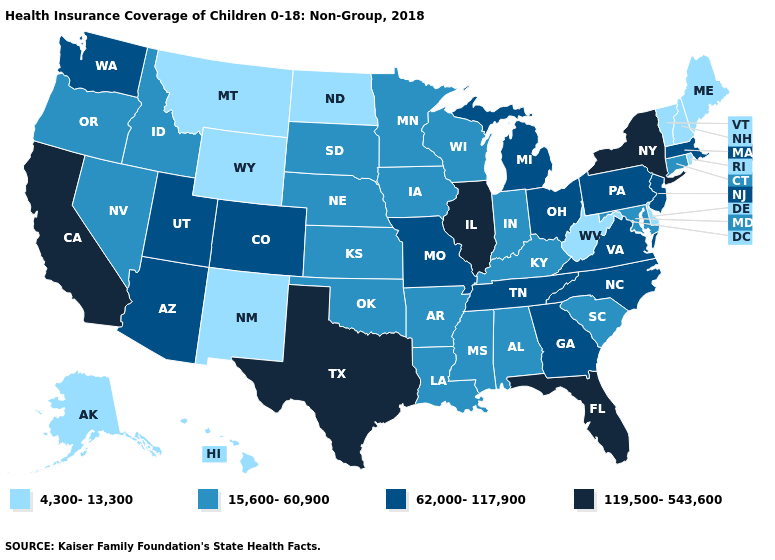Does the map have missing data?
Be succinct. No. What is the value of Illinois?
Keep it brief. 119,500-543,600. Which states have the highest value in the USA?
Keep it brief. California, Florida, Illinois, New York, Texas. Is the legend a continuous bar?
Quick response, please. No. Name the states that have a value in the range 4,300-13,300?
Give a very brief answer. Alaska, Delaware, Hawaii, Maine, Montana, New Hampshire, New Mexico, North Dakota, Rhode Island, Vermont, West Virginia, Wyoming. What is the value of New Hampshire?
Write a very short answer. 4,300-13,300. Does Montana have a higher value than Michigan?
Quick response, please. No. Does New York have the same value as Colorado?
Answer briefly. No. Does the map have missing data?
Short answer required. No. What is the value of California?
Write a very short answer. 119,500-543,600. Is the legend a continuous bar?
Concise answer only. No. Name the states that have a value in the range 4,300-13,300?
Write a very short answer. Alaska, Delaware, Hawaii, Maine, Montana, New Hampshire, New Mexico, North Dakota, Rhode Island, Vermont, West Virginia, Wyoming. Does Illinois have the highest value in the USA?
Write a very short answer. Yes. Name the states that have a value in the range 119,500-543,600?
Write a very short answer. California, Florida, Illinois, New York, Texas. What is the highest value in the USA?
Be succinct. 119,500-543,600. 